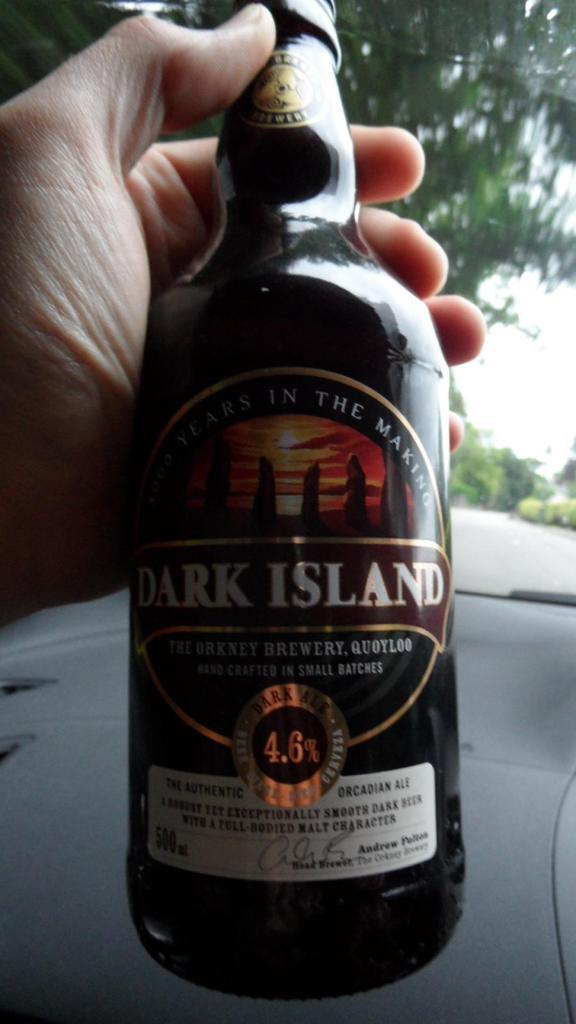<image>
Create a compact narrative representing the image presented. A man holds a bottle of Dark Island in his hand. 